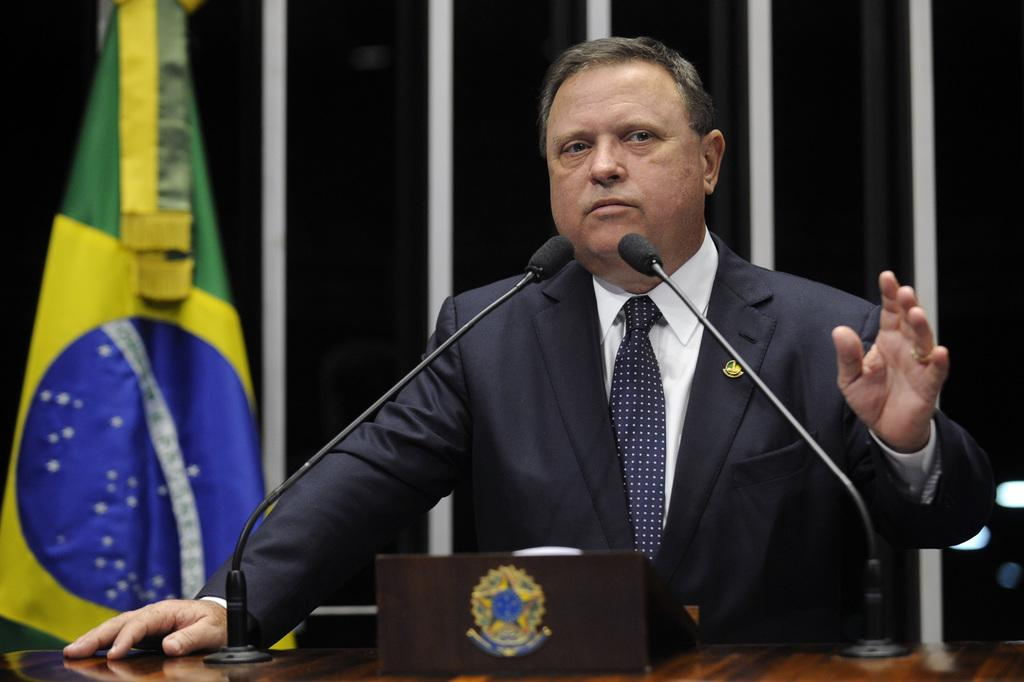Who is the main subject in the image? There is a man in the center of the image. What is the man doing in the image? The man is standing in the image. What is in front of the man? There is a podium in front of the man. What is placed on the podium? Mics are placed on the podium. What can be seen in the background of the image? There is a flag and a curtain in the background. What type of nerve can be seen in the image? There is no nerve present in the image. What kind of creature is standing next to the man in the image? There is no creature standing next to the man in the image; only the man, podium, mics, flag, and curtain are present. 